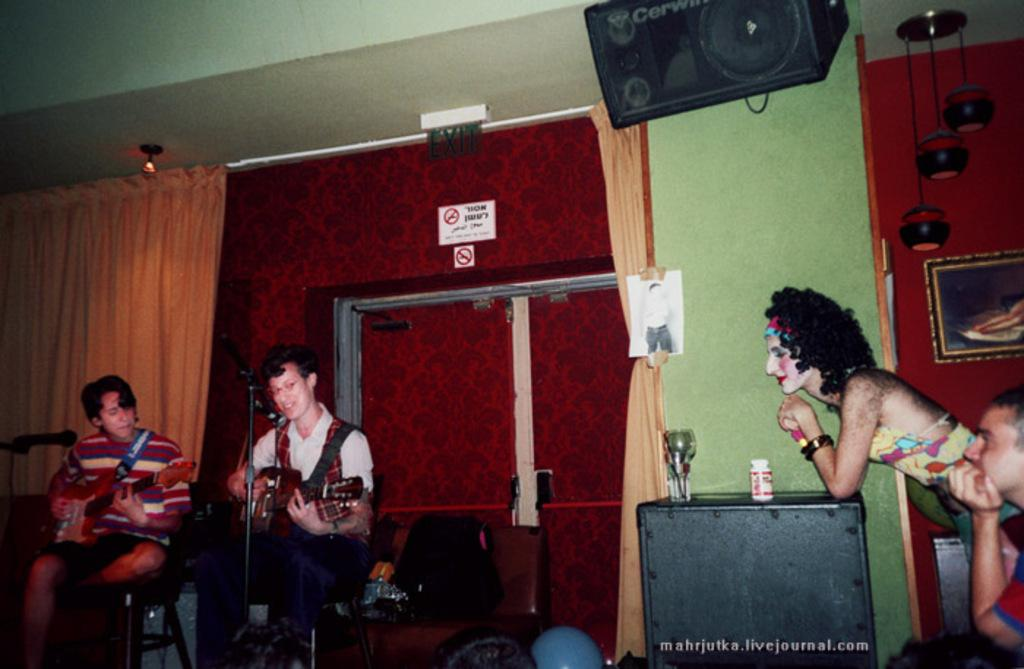How many people are in the image? There are two men in the image. What are the men doing in the image? The men are sitting and playing guitars. What objects are in front of the men? There are microphones in front of the men. Who else is present in the image? There is a woman standing beside the men. What is the woman doing in the image? The woman is listening to the men play guitars. What type of gate can be seen in the image? There is no gate present in the image. Where is the lake located in the image? There is no lake present in the image. 